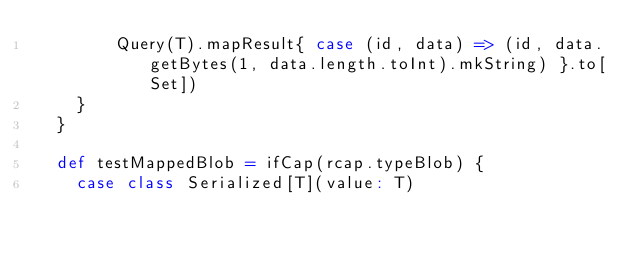<code> <loc_0><loc_0><loc_500><loc_500><_Scala_>        Query(T).mapResult{ case (id, data) => (id, data.getBytes(1, data.length.toInt).mkString) }.to[Set])
    }
  }

  def testMappedBlob = ifCap(rcap.typeBlob) {
    case class Serialized[T](value: T)
</code> 